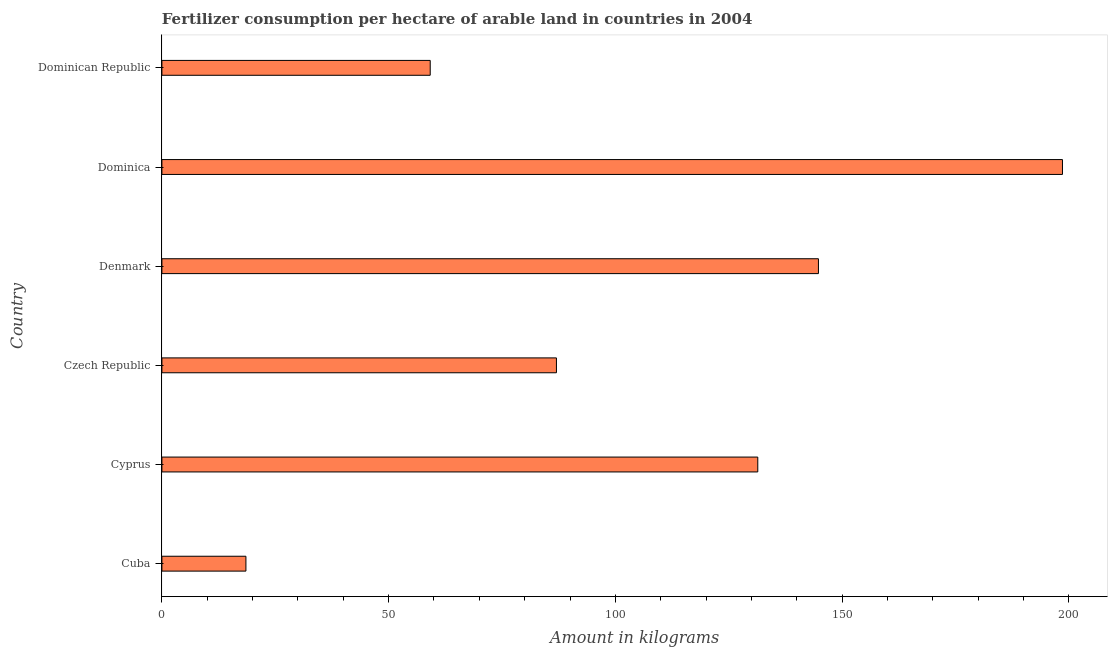Does the graph contain any zero values?
Offer a very short reply. No. Does the graph contain grids?
Your response must be concise. No. What is the title of the graph?
Ensure brevity in your answer.  Fertilizer consumption per hectare of arable land in countries in 2004 . What is the label or title of the X-axis?
Ensure brevity in your answer.  Amount in kilograms. What is the label or title of the Y-axis?
Offer a very short reply. Country. What is the amount of fertilizer consumption in Cuba?
Your response must be concise. 18.53. Across all countries, what is the maximum amount of fertilizer consumption?
Your answer should be very brief. 198.6. Across all countries, what is the minimum amount of fertilizer consumption?
Provide a short and direct response. 18.53. In which country was the amount of fertilizer consumption maximum?
Your answer should be compact. Dominica. In which country was the amount of fertilizer consumption minimum?
Ensure brevity in your answer.  Cuba. What is the sum of the amount of fertilizer consumption?
Make the answer very short. 639.5. What is the difference between the amount of fertilizer consumption in Cyprus and Dominican Republic?
Your answer should be very brief. 72.23. What is the average amount of fertilizer consumption per country?
Give a very brief answer. 106.58. What is the median amount of fertilizer consumption?
Ensure brevity in your answer.  109.21. In how many countries, is the amount of fertilizer consumption greater than 100 kg?
Provide a succinct answer. 3. What is the ratio of the amount of fertilizer consumption in Cyprus to that in Denmark?
Your answer should be very brief. 0.91. Is the difference between the amount of fertilizer consumption in Dominica and Dominican Republic greater than the difference between any two countries?
Provide a short and direct response. No. What is the difference between the highest and the second highest amount of fertilizer consumption?
Offer a very short reply. 53.82. What is the difference between the highest and the lowest amount of fertilizer consumption?
Ensure brevity in your answer.  180.07. In how many countries, is the amount of fertilizer consumption greater than the average amount of fertilizer consumption taken over all countries?
Make the answer very short. 3. How many bars are there?
Provide a succinct answer. 6. What is the Amount in kilograms of Cuba?
Provide a succinct answer. 18.53. What is the Amount in kilograms of Cyprus?
Ensure brevity in your answer.  131.41. What is the Amount in kilograms of Czech Republic?
Offer a terse response. 87.01. What is the Amount in kilograms in Denmark?
Provide a short and direct response. 144.78. What is the Amount in kilograms of Dominica?
Make the answer very short. 198.6. What is the Amount in kilograms of Dominican Republic?
Your response must be concise. 59.17. What is the difference between the Amount in kilograms in Cuba and Cyprus?
Keep it short and to the point. -112.88. What is the difference between the Amount in kilograms in Cuba and Czech Republic?
Ensure brevity in your answer.  -68.48. What is the difference between the Amount in kilograms in Cuba and Denmark?
Provide a short and direct response. -126.25. What is the difference between the Amount in kilograms in Cuba and Dominica?
Your answer should be compact. -180.07. What is the difference between the Amount in kilograms in Cuba and Dominican Republic?
Ensure brevity in your answer.  -40.64. What is the difference between the Amount in kilograms in Cyprus and Czech Republic?
Ensure brevity in your answer.  44.4. What is the difference between the Amount in kilograms in Cyprus and Denmark?
Offer a very short reply. -13.38. What is the difference between the Amount in kilograms in Cyprus and Dominica?
Keep it short and to the point. -67.19. What is the difference between the Amount in kilograms in Cyprus and Dominican Republic?
Provide a short and direct response. 72.23. What is the difference between the Amount in kilograms in Czech Republic and Denmark?
Provide a succinct answer. -57.78. What is the difference between the Amount in kilograms in Czech Republic and Dominica?
Provide a short and direct response. -111.59. What is the difference between the Amount in kilograms in Czech Republic and Dominican Republic?
Your response must be concise. 27.83. What is the difference between the Amount in kilograms in Denmark and Dominica?
Ensure brevity in your answer.  -53.82. What is the difference between the Amount in kilograms in Denmark and Dominican Republic?
Your answer should be compact. 85.61. What is the difference between the Amount in kilograms in Dominica and Dominican Republic?
Ensure brevity in your answer.  139.43. What is the ratio of the Amount in kilograms in Cuba to that in Cyprus?
Ensure brevity in your answer.  0.14. What is the ratio of the Amount in kilograms in Cuba to that in Czech Republic?
Offer a very short reply. 0.21. What is the ratio of the Amount in kilograms in Cuba to that in Denmark?
Your answer should be very brief. 0.13. What is the ratio of the Amount in kilograms in Cuba to that in Dominica?
Offer a very short reply. 0.09. What is the ratio of the Amount in kilograms in Cuba to that in Dominican Republic?
Provide a short and direct response. 0.31. What is the ratio of the Amount in kilograms in Cyprus to that in Czech Republic?
Provide a succinct answer. 1.51. What is the ratio of the Amount in kilograms in Cyprus to that in Denmark?
Provide a short and direct response. 0.91. What is the ratio of the Amount in kilograms in Cyprus to that in Dominica?
Make the answer very short. 0.66. What is the ratio of the Amount in kilograms in Cyprus to that in Dominican Republic?
Provide a succinct answer. 2.22. What is the ratio of the Amount in kilograms in Czech Republic to that in Denmark?
Offer a terse response. 0.6. What is the ratio of the Amount in kilograms in Czech Republic to that in Dominica?
Offer a very short reply. 0.44. What is the ratio of the Amount in kilograms in Czech Republic to that in Dominican Republic?
Ensure brevity in your answer.  1.47. What is the ratio of the Amount in kilograms in Denmark to that in Dominica?
Your answer should be very brief. 0.73. What is the ratio of the Amount in kilograms in Denmark to that in Dominican Republic?
Make the answer very short. 2.45. What is the ratio of the Amount in kilograms in Dominica to that in Dominican Republic?
Your answer should be very brief. 3.36. 